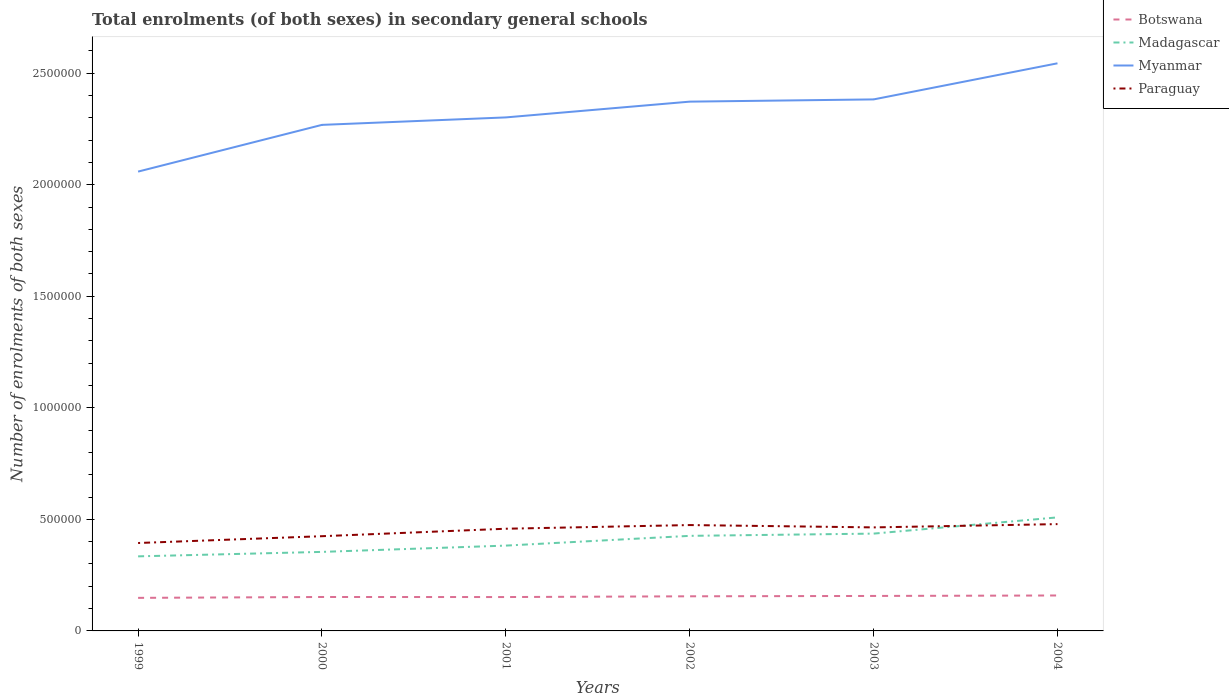How many different coloured lines are there?
Make the answer very short. 4. Does the line corresponding to Paraguay intersect with the line corresponding to Myanmar?
Make the answer very short. No. Across all years, what is the maximum number of enrolments in secondary schools in Paraguay?
Your answer should be very brief. 3.94e+05. What is the total number of enrolments in secondary schools in Paraguay in the graph?
Your answer should be compact. -3.94e+04. What is the difference between the highest and the second highest number of enrolments in secondary schools in Myanmar?
Make the answer very short. 4.85e+05. Is the number of enrolments in secondary schools in Myanmar strictly greater than the number of enrolments in secondary schools in Botswana over the years?
Your answer should be very brief. No. How many lines are there?
Provide a short and direct response. 4. What is the difference between two consecutive major ticks on the Y-axis?
Give a very brief answer. 5.00e+05. How are the legend labels stacked?
Offer a very short reply. Vertical. What is the title of the graph?
Your answer should be compact. Total enrolments (of both sexes) in secondary general schools. What is the label or title of the X-axis?
Ensure brevity in your answer.  Years. What is the label or title of the Y-axis?
Your answer should be very brief. Number of enrolments of both sexes. What is the Number of enrolments of both sexes in Botswana in 1999?
Provide a short and direct response. 1.48e+05. What is the Number of enrolments of both sexes in Madagascar in 1999?
Give a very brief answer. 3.34e+05. What is the Number of enrolments of both sexes in Myanmar in 1999?
Provide a short and direct response. 2.06e+06. What is the Number of enrolments of both sexes in Paraguay in 1999?
Your response must be concise. 3.94e+05. What is the Number of enrolments of both sexes of Botswana in 2000?
Provide a short and direct response. 1.52e+05. What is the Number of enrolments of both sexes in Madagascar in 2000?
Offer a very short reply. 3.54e+05. What is the Number of enrolments of both sexes of Myanmar in 2000?
Your response must be concise. 2.27e+06. What is the Number of enrolments of both sexes of Paraguay in 2000?
Your response must be concise. 4.25e+05. What is the Number of enrolments of both sexes in Botswana in 2001?
Offer a very short reply. 1.52e+05. What is the Number of enrolments of both sexes of Madagascar in 2001?
Give a very brief answer. 3.82e+05. What is the Number of enrolments of both sexes of Myanmar in 2001?
Your response must be concise. 2.30e+06. What is the Number of enrolments of both sexes in Paraguay in 2001?
Your answer should be compact. 4.58e+05. What is the Number of enrolments of both sexes of Botswana in 2002?
Your answer should be very brief. 1.55e+05. What is the Number of enrolments of both sexes of Madagascar in 2002?
Offer a terse response. 4.26e+05. What is the Number of enrolments of both sexes in Myanmar in 2002?
Provide a succinct answer. 2.37e+06. What is the Number of enrolments of both sexes in Paraguay in 2002?
Give a very brief answer. 4.75e+05. What is the Number of enrolments of both sexes in Botswana in 2003?
Give a very brief answer. 1.57e+05. What is the Number of enrolments of both sexes in Madagascar in 2003?
Your answer should be very brief. 4.36e+05. What is the Number of enrolments of both sexes in Myanmar in 2003?
Your response must be concise. 2.38e+06. What is the Number of enrolments of both sexes of Paraguay in 2003?
Keep it short and to the point. 4.64e+05. What is the Number of enrolments of both sexes in Botswana in 2004?
Your answer should be compact. 1.59e+05. What is the Number of enrolments of both sexes of Madagascar in 2004?
Give a very brief answer. 5.09e+05. What is the Number of enrolments of both sexes of Myanmar in 2004?
Your answer should be very brief. 2.54e+06. What is the Number of enrolments of both sexes of Paraguay in 2004?
Your answer should be compact. 4.79e+05. Across all years, what is the maximum Number of enrolments of both sexes of Botswana?
Your response must be concise. 1.59e+05. Across all years, what is the maximum Number of enrolments of both sexes in Madagascar?
Make the answer very short. 5.09e+05. Across all years, what is the maximum Number of enrolments of both sexes in Myanmar?
Your response must be concise. 2.54e+06. Across all years, what is the maximum Number of enrolments of both sexes of Paraguay?
Offer a terse response. 4.79e+05. Across all years, what is the minimum Number of enrolments of both sexes in Botswana?
Give a very brief answer. 1.48e+05. Across all years, what is the minimum Number of enrolments of both sexes of Madagascar?
Your response must be concise. 3.34e+05. Across all years, what is the minimum Number of enrolments of both sexes in Myanmar?
Your response must be concise. 2.06e+06. Across all years, what is the minimum Number of enrolments of both sexes in Paraguay?
Your answer should be very brief. 3.94e+05. What is the total Number of enrolments of both sexes of Botswana in the graph?
Keep it short and to the point. 9.23e+05. What is the total Number of enrolments of both sexes of Madagascar in the graph?
Provide a succinct answer. 2.44e+06. What is the total Number of enrolments of both sexes of Myanmar in the graph?
Give a very brief answer. 1.39e+07. What is the total Number of enrolments of both sexes in Paraguay in the graph?
Offer a terse response. 2.69e+06. What is the difference between the Number of enrolments of both sexes of Botswana in 1999 and that in 2000?
Offer a very short reply. -3910. What is the difference between the Number of enrolments of both sexes of Madagascar in 1999 and that in 2000?
Provide a succinct answer. -2.00e+04. What is the difference between the Number of enrolments of both sexes in Myanmar in 1999 and that in 2000?
Keep it short and to the point. -2.09e+05. What is the difference between the Number of enrolments of both sexes of Paraguay in 1999 and that in 2000?
Make the answer very short. -3.05e+04. What is the difference between the Number of enrolments of both sexes of Botswana in 1999 and that in 2001?
Your answer should be compact. -3652. What is the difference between the Number of enrolments of both sexes of Madagascar in 1999 and that in 2001?
Your answer should be compact. -4.82e+04. What is the difference between the Number of enrolments of both sexes of Myanmar in 1999 and that in 2001?
Provide a succinct answer. -2.43e+05. What is the difference between the Number of enrolments of both sexes of Paraguay in 1999 and that in 2001?
Provide a short and direct response. -6.40e+04. What is the difference between the Number of enrolments of both sexes of Botswana in 1999 and that in 2002?
Your answer should be very brief. -7012. What is the difference between the Number of enrolments of both sexes in Madagascar in 1999 and that in 2002?
Provide a succinct answer. -9.19e+04. What is the difference between the Number of enrolments of both sexes of Myanmar in 1999 and that in 2002?
Make the answer very short. -3.14e+05. What is the difference between the Number of enrolments of both sexes of Paraguay in 1999 and that in 2002?
Make the answer very short. -8.05e+04. What is the difference between the Number of enrolments of both sexes in Botswana in 1999 and that in 2003?
Offer a terse response. -8591. What is the difference between the Number of enrolments of both sexes in Madagascar in 1999 and that in 2003?
Give a very brief answer. -1.02e+05. What is the difference between the Number of enrolments of both sexes of Myanmar in 1999 and that in 2003?
Make the answer very short. -3.24e+05. What is the difference between the Number of enrolments of both sexes in Paraguay in 1999 and that in 2003?
Your response must be concise. -7.00e+04. What is the difference between the Number of enrolments of both sexes in Botswana in 1999 and that in 2004?
Ensure brevity in your answer.  -1.06e+04. What is the difference between the Number of enrolments of both sexes of Madagascar in 1999 and that in 2004?
Offer a very short reply. -1.75e+05. What is the difference between the Number of enrolments of both sexes of Myanmar in 1999 and that in 2004?
Provide a short and direct response. -4.85e+05. What is the difference between the Number of enrolments of both sexes of Paraguay in 1999 and that in 2004?
Your response must be concise. -8.47e+04. What is the difference between the Number of enrolments of both sexes in Botswana in 2000 and that in 2001?
Give a very brief answer. 258. What is the difference between the Number of enrolments of both sexes of Madagascar in 2000 and that in 2001?
Offer a very short reply. -2.82e+04. What is the difference between the Number of enrolments of both sexes of Myanmar in 2000 and that in 2001?
Ensure brevity in your answer.  -3.35e+04. What is the difference between the Number of enrolments of both sexes in Paraguay in 2000 and that in 2001?
Provide a succinct answer. -3.35e+04. What is the difference between the Number of enrolments of both sexes in Botswana in 2000 and that in 2002?
Keep it short and to the point. -3102. What is the difference between the Number of enrolments of both sexes of Madagascar in 2000 and that in 2002?
Keep it short and to the point. -7.19e+04. What is the difference between the Number of enrolments of both sexes of Myanmar in 2000 and that in 2002?
Offer a very short reply. -1.04e+05. What is the difference between the Number of enrolments of both sexes in Paraguay in 2000 and that in 2002?
Offer a terse response. -4.99e+04. What is the difference between the Number of enrolments of both sexes in Botswana in 2000 and that in 2003?
Keep it short and to the point. -4681. What is the difference between the Number of enrolments of both sexes in Madagascar in 2000 and that in 2003?
Give a very brief answer. -8.20e+04. What is the difference between the Number of enrolments of both sexes in Myanmar in 2000 and that in 2003?
Your answer should be very brief. -1.14e+05. What is the difference between the Number of enrolments of both sexes of Paraguay in 2000 and that in 2003?
Make the answer very short. -3.94e+04. What is the difference between the Number of enrolments of both sexes in Botswana in 2000 and that in 2004?
Your answer should be compact. -6734. What is the difference between the Number of enrolments of both sexes in Madagascar in 2000 and that in 2004?
Keep it short and to the point. -1.55e+05. What is the difference between the Number of enrolments of both sexes in Myanmar in 2000 and that in 2004?
Make the answer very short. -2.76e+05. What is the difference between the Number of enrolments of both sexes of Paraguay in 2000 and that in 2004?
Your answer should be compact. -5.42e+04. What is the difference between the Number of enrolments of both sexes of Botswana in 2001 and that in 2002?
Ensure brevity in your answer.  -3360. What is the difference between the Number of enrolments of both sexes in Madagascar in 2001 and that in 2002?
Your answer should be compact. -4.37e+04. What is the difference between the Number of enrolments of both sexes in Myanmar in 2001 and that in 2002?
Your answer should be compact. -7.07e+04. What is the difference between the Number of enrolments of both sexes in Paraguay in 2001 and that in 2002?
Offer a very short reply. -1.65e+04. What is the difference between the Number of enrolments of both sexes in Botswana in 2001 and that in 2003?
Offer a terse response. -4939. What is the difference between the Number of enrolments of both sexes of Madagascar in 2001 and that in 2003?
Your answer should be compact. -5.37e+04. What is the difference between the Number of enrolments of both sexes of Myanmar in 2001 and that in 2003?
Keep it short and to the point. -8.07e+04. What is the difference between the Number of enrolments of both sexes in Paraguay in 2001 and that in 2003?
Provide a succinct answer. -5988. What is the difference between the Number of enrolments of both sexes in Botswana in 2001 and that in 2004?
Ensure brevity in your answer.  -6992. What is the difference between the Number of enrolments of both sexes in Madagascar in 2001 and that in 2004?
Offer a terse response. -1.26e+05. What is the difference between the Number of enrolments of both sexes in Myanmar in 2001 and that in 2004?
Offer a terse response. -2.43e+05. What is the difference between the Number of enrolments of both sexes of Paraguay in 2001 and that in 2004?
Make the answer very short. -2.07e+04. What is the difference between the Number of enrolments of both sexes in Botswana in 2002 and that in 2003?
Offer a terse response. -1579. What is the difference between the Number of enrolments of both sexes of Madagascar in 2002 and that in 2003?
Keep it short and to the point. -1.00e+04. What is the difference between the Number of enrolments of both sexes in Myanmar in 2002 and that in 2003?
Provide a short and direct response. -1.00e+04. What is the difference between the Number of enrolments of both sexes of Paraguay in 2002 and that in 2003?
Give a very brief answer. 1.05e+04. What is the difference between the Number of enrolments of both sexes in Botswana in 2002 and that in 2004?
Your answer should be compact. -3632. What is the difference between the Number of enrolments of both sexes in Madagascar in 2002 and that in 2004?
Offer a terse response. -8.28e+04. What is the difference between the Number of enrolments of both sexes of Myanmar in 2002 and that in 2004?
Ensure brevity in your answer.  -1.72e+05. What is the difference between the Number of enrolments of both sexes in Paraguay in 2002 and that in 2004?
Make the answer very short. -4249. What is the difference between the Number of enrolments of both sexes in Botswana in 2003 and that in 2004?
Ensure brevity in your answer.  -2053. What is the difference between the Number of enrolments of both sexes in Madagascar in 2003 and that in 2004?
Give a very brief answer. -7.28e+04. What is the difference between the Number of enrolments of both sexes of Myanmar in 2003 and that in 2004?
Your answer should be compact. -1.62e+05. What is the difference between the Number of enrolments of both sexes in Paraguay in 2003 and that in 2004?
Offer a very short reply. -1.47e+04. What is the difference between the Number of enrolments of both sexes of Botswana in 1999 and the Number of enrolments of both sexes of Madagascar in 2000?
Provide a short and direct response. -2.06e+05. What is the difference between the Number of enrolments of both sexes of Botswana in 1999 and the Number of enrolments of both sexes of Myanmar in 2000?
Ensure brevity in your answer.  -2.12e+06. What is the difference between the Number of enrolments of both sexes of Botswana in 1999 and the Number of enrolments of both sexes of Paraguay in 2000?
Ensure brevity in your answer.  -2.76e+05. What is the difference between the Number of enrolments of both sexes in Madagascar in 1999 and the Number of enrolments of both sexes in Myanmar in 2000?
Give a very brief answer. -1.93e+06. What is the difference between the Number of enrolments of both sexes in Madagascar in 1999 and the Number of enrolments of both sexes in Paraguay in 2000?
Offer a terse response. -9.04e+04. What is the difference between the Number of enrolments of both sexes of Myanmar in 1999 and the Number of enrolments of both sexes of Paraguay in 2000?
Keep it short and to the point. 1.63e+06. What is the difference between the Number of enrolments of both sexes in Botswana in 1999 and the Number of enrolments of both sexes in Madagascar in 2001?
Your answer should be very brief. -2.34e+05. What is the difference between the Number of enrolments of both sexes in Botswana in 1999 and the Number of enrolments of both sexes in Myanmar in 2001?
Your answer should be compact. -2.15e+06. What is the difference between the Number of enrolments of both sexes in Botswana in 1999 and the Number of enrolments of both sexes in Paraguay in 2001?
Offer a terse response. -3.10e+05. What is the difference between the Number of enrolments of both sexes of Madagascar in 1999 and the Number of enrolments of both sexes of Myanmar in 2001?
Make the answer very short. -1.97e+06. What is the difference between the Number of enrolments of both sexes of Madagascar in 1999 and the Number of enrolments of both sexes of Paraguay in 2001?
Keep it short and to the point. -1.24e+05. What is the difference between the Number of enrolments of both sexes of Myanmar in 1999 and the Number of enrolments of both sexes of Paraguay in 2001?
Give a very brief answer. 1.60e+06. What is the difference between the Number of enrolments of both sexes of Botswana in 1999 and the Number of enrolments of both sexes of Madagascar in 2002?
Offer a very short reply. -2.78e+05. What is the difference between the Number of enrolments of both sexes of Botswana in 1999 and the Number of enrolments of both sexes of Myanmar in 2002?
Your response must be concise. -2.22e+06. What is the difference between the Number of enrolments of both sexes of Botswana in 1999 and the Number of enrolments of both sexes of Paraguay in 2002?
Your answer should be compact. -3.26e+05. What is the difference between the Number of enrolments of both sexes of Madagascar in 1999 and the Number of enrolments of both sexes of Myanmar in 2002?
Give a very brief answer. -2.04e+06. What is the difference between the Number of enrolments of both sexes of Madagascar in 1999 and the Number of enrolments of both sexes of Paraguay in 2002?
Offer a terse response. -1.40e+05. What is the difference between the Number of enrolments of both sexes in Myanmar in 1999 and the Number of enrolments of both sexes in Paraguay in 2002?
Give a very brief answer. 1.58e+06. What is the difference between the Number of enrolments of both sexes in Botswana in 1999 and the Number of enrolments of both sexes in Madagascar in 2003?
Offer a terse response. -2.88e+05. What is the difference between the Number of enrolments of both sexes of Botswana in 1999 and the Number of enrolments of both sexes of Myanmar in 2003?
Your response must be concise. -2.23e+06. What is the difference between the Number of enrolments of both sexes in Botswana in 1999 and the Number of enrolments of both sexes in Paraguay in 2003?
Your answer should be very brief. -3.16e+05. What is the difference between the Number of enrolments of both sexes of Madagascar in 1999 and the Number of enrolments of both sexes of Myanmar in 2003?
Give a very brief answer. -2.05e+06. What is the difference between the Number of enrolments of both sexes in Madagascar in 1999 and the Number of enrolments of both sexes in Paraguay in 2003?
Give a very brief answer. -1.30e+05. What is the difference between the Number of enrolments of both sexes in Myanmar in 1999 and the Number of enrolments of both sexes in Paraguay in 2003?
Your response must be concise. 1.59e+06. What is the difference between the Number of enrolments of both sexes of Botswana in 1999 and the Number of enrolments of both sexes of Madagascar in 2004?
Make the answer very short. -3.61e+05. What is the difference between the Number of enrolments of both sexes in Botswana in 1999 and the Number of enrolments of both sexes in Myanmar in 2004?
Provide a succinct answer. -2.40e+06. What is the difference between the Number of enrolments of both sexes of Botswana in 1999 and the Number of enrolments of both sexes of Paraguay in 2004?
Your answer should be very brief. -3.31e+05. What is the difference between the Number of enrolments of both sexes in Madagascar in 1999 and the Number of enrolments of both sexes in Myanmar in 2004?
Your answer should be compact. -2.21e+06. What is the difference between the Number of enrolments of both sexes in Madagascar in 1999 and the Number of enrolments of both sexes in Paraguay in 2004?
Your response must be concise. -1.45e+05. What is the difference between the Number of enrolments of both sexes of Myanmar in 1999 and the Number of enrolments of both sexes of Paraguay in 2004?
Your answer should be compact. 1.58e+06. What is the difference between the Number of enrolments of both sexes in Botswana in 2000 and the Number of enrolments of both sexes in Madagascar in 2001?
Ensure brevity in your answer.  -2.30e+05. What is the difference between the Number of enrolments of both sexes in Botswana in 2000 and the Number of enrolments of both sexes in Myanmar in 2001?
Keep it short and to the point. -2.15e+06. What is the difference between the Number of enrolments of both sexes in Botswana in 2000 and the Number of enrolments of both sexes in Paraguay in 2001?
Offer a very short reply. -3.06e+05. What is the difference between the Number of enrolments of both sexes in Madagascar in 2000 and the Number of enrolments of both sexes in Myanmar in 2001?
Your response must be concise. -1.95e+06. What is the difference between the Number of enrolments of both sexes of Madagascar in 2000 and the Number of enrolments of both sexes of Paraguay in 2001?
Provide a succinct answer. -1.04e+05. What is the difference between the Number of enrolments of both sexes in Myanmar in 2000 and the Number of enrolments of both sexes in Paraguay in 2001?
Your answer should be very brief. 1.81e+06. What is the difference between the Number of enrolments of both sexes of Botswana in 2000 and the Number of enrolments of both sexes of Madagascar in 2002?
Offer a terse response. -2.74e+05. What is the difference between the Number of enrolments of both sexes in Botswana in 2000 and the Number of enrolments of both sexes in Myanmar in 2002?
Keep it short and to the point. -2.22e+06. What is the difference between the Number of enrolments of both sexes in Botswana in 2000 and the Number of enrolments of both sexes in Paraguay in 2002?
Your answer should be compact. -3.22e+05. What is the difference between the Number of enrolments of both sexes in Madagascar in 2000 and the Number of enrolments of both sexes in Myanmar in 2002?
Make the answer very short. -2.02e+06. What is the difference between the Number of enrolments of both sexes of Madagascar in 2000 and the Number of enrolments of both sexes of Paraguay in 2002?
Give a very brief answer. -1.20e+05. What is the difference between the Number of enrolments of both sexes in Myanmar in 2000 and the Number of enrolments of both sexes in Paraguay in 2002?
Provide a succinct answer. 1.79e+06. What is the difference between the Number of enrolments of both sexes of Botswana in 2000 and the Number of enrolments of both sexes of Madagascar in 2003?
Ensure brevity in your answer.  -2.84e+05. What is the difference between the Number of enrolments of both sexes in Botswana in 2000 and the Number of enrolments of both sexes in Myanmar in 2003?
Make the answer very short. -2.23e+06. What is the difference between the Number of enrolments of both sexes in Botswana in 2000 and the Number of enrolments of both sexes in Paraguay in 2003?
Offer a very short reply. -3.12e+05. What is the difference between the Number of enrolments of both sexes in Madagascar in 2000 and the Number of enrolments of both sexes in Myanmar in 2003?
Your answer should be very brief. -2.03e+06. What is the difference between the Number of enrolments of both sexes in Madagascar in 2000 and the Number of enrolments of both sexes in Paraguay in 2003?
Ensure brevity in your answer.  -1.10e+05. What is the difference between the Number of enrolments of both sexes in Myanmar in 2000 and the Number of enrolments of both sexes in Paraguay in 2003?
Keep it short and to the point. 1.80e+06. What is the difference between the Number of enrolments of both sexes in Botswana in 2000 and the Number of enrolments of both sexes in Madagascar in 2004?
Provide a short and direct response. -3.57e+05. What is the difference between the Number of enrolments of both sexes of Botswana in 2000 and the Number of enrolments of both sexes of Myanmar in 2004?
Your answer should be compact. -2.39e+06. What is the difference between the Number of enrolments of both sexes in Botswana in 2000 and the Number of enrolments of both sexes in Paraguay in 2004?
Make the answer very short. -3.27e+05. What is the difference between the Number of enrolments of both sexes of Madagascar in 2000 and the Number of enrolments of both sexes of Myanmar in 2004?
Ensure brevity in your answer.  -2.19e+06. What is the difference between the Number of enrolments of both sexes of Madagascar in 2000 and the Number of enrolments of both sexes of Paraguay in 2004?
Keep it short and to the point. -1.25e+05. What is the difference between the Number of enrolments of both sexes of Myanmar in 2000 and the Number of enrolments of both sexes of Paraguay in 2004?
Provide a short and direct response. 1.79e+06. What is the difference between the Number of enrolments of both sexes of Botswana in 2001 and the Number of enrolments of both sexes of Madagascar in 2002?
Ensure brevity in your answer.  -2.74e+05. What is the difference between the Number of enrolments of both sexes of Botswana in 2001 and the Number of enrolments of both sexes of Myanmar in 2002?
Ensure brevity in your answer.  -2.22e+06. What is the difference between the Number of enrolments of both sexes of Botswana in 2001 and the Number of enrolments of both sexes of Paraguay in 2002?
Make the answer very short. -3.23e+05. What is the difference between the Number of enrolments of both sexes of Madagascar in 2001 and the Number of enrolments of both sexes of Myanmar in 2002?
Your answer should be compact. -1.99e+06. What is the difference between the Number of enrolments of both sexes of Madagascar in 2001 and the Number of enrolments of both sexes of Paraguay in 2002?
Your answer should be very brief. -9.21e+04. What is the difference between the Number of enrolments of both sexes of Myanmar in 2001 and the Number of enrolments of both sexes of Paraguay in 2002?
Provide a short and direct response. 1.83e+06. What is the difference between the Number of enrolments of both sexes in Botswana in 2001 and the Number of enrolments of both sexes in Madagascar in 2003?
Your answer should be very brief. -2.84e+05. What is the difference between the Number of enrolments of both sexes of Botswana in 2001 and the Number of enrolments of both sexes of Myanmar in 2003?
Offer a terse response. -2.23e+06. What is the difference between the Number of enrolments of both sexes in Botswana in 2001 and the Number of enrolments of both sexes in Paraguay in 2003?
Your answer should be very brief. -3.12e+05. What is the difference between the Number of enrolments of both sexes in Madagascar in 2001 and the Number of enrolments of both sexes in Myanmar in 2003?
Give a very brief answer. -2.00e+06. What is the difference between the Number of enrolments of both sexes of Madagascar in 2001 and the Number of enrolments of both sexes of Paraguay in 2003?
Offer a very short reply. -8.16e+04. What is the difference between the Number of enrolments of both sexes in Myanmar in 2001 and the Number of enrolments of both sexes in Paraguay in 2003?
Keep it short and to the point. 1.84e+06. What is the difference between the Number of enrolments of both sexes of Botswana in 2001 and the Number of enrolments of both sexes of Madagascar in 2004?
Provide a short and direct response. -3.57e+05. What is the difference between the Number of enrolments of both sexes in Botswana in 2001 and the Number of enrolments of both sexes in Myanmar in 2004?
Your answer should be compact. -2.39e+06. What is the difference between the Number of enrolments of both sexes in Botswana in 2001 and the Number of enrolments of both sexes in Paraguay in 2004?
Provide a short and direct response. -3.27e+05. What is the difference between the Number of enrolments of both sexes of Madagascar in 2001 and the Number of enrolments of both sexes of Myanmar in 2004?
Keep it short and to the point. -2.16e+06. What is the difference between the Number of enrolments of both sexes in Madagascar in 2001 and the Number of enrolments of both sexes in Paraguay in 2004?
Ensure brevity in your answer.  -9.63e+04. What is the difference between the Number of enrolments of both sexes in Myanmar in 2001 and the Number of enrolments of both sexes in Paraguay in 2004?
Offer a terse response. 1.82e+06. What is the difference between the Number of enrolments of both sexes of Botswana in 2002 and the Number of enrolments of both sexes of Madagascar in 2003?
Give a very brief answer. -2.81e+05. What is the difference between the Number of enrolments of both sexes of Botswana in 2002 and the Number of enrolments of both sexes of Myanmar in 2003?
Your answer should be compact. -2.23e+06. What is the difference between the Number of enrolments of both sexes in Botswana in 2002 and the Number of enrolments of both sexes in Paraguay in 2003?
Your response must be concise. -3.09e+05. What is the difference between the Number of enrolments of both sexes of Madagascar in 2002 and the Number of enrolments of both sexes of Myanmar in 2003?
Ensure brevity in your answer.  -1.96e+06. What is the difference between the Number of enrolments of both sexes of Madagascar in 2002 and the Number of enrolments of both sexes of Paraguay in 2003?
Ensure brevity in your answer.  -3.79e+04. What is the difference between the Number of enrolments of both sexes of Myanmar in 2002 and the Number of enrolments of both sexes of Paraguay in 2003?
Offer a very short reply. 1.91e+06. What is the difference between the Number of enrolments of both sexes of Botswana in 2002 and the Number of enrolments of both sexes of Madagascar in 2004?
Give a very brief answer. -3.54e+05. What is the difference between the Number of enrolments of both sexes of Botswana in 2002 and the Number of enrolments of both sexes of Myanmar in 2004?
Make the answer very short. -2.39e+06. What is the difference between the Number of enrolments of both sexes in Botswana in 2002 and the Number of enrolments of both sexes in Paraguay in 2004?
Keep it short and to the point. -3.24e+05. What is the difference between the Number of enrolments of both sexes of Madagascar in 2002 and the Number of enrolments of both sexes of Myanmar in 2004?
Your response must be concise. -2.12e+06. What is the difference between the Number of enrolments of both sexes of Madagascar in 2002 and the Number of enrolments of both sexes of Paraguay in 2004?
Provide a succinct answer. -5.26e+04. What is the difference between the Number of enrolments of both sexes of Myanmar in 2002 and the Number of enrolments of both sexes of Paraguay in 2004?
Provide a succinct answer. 1.89e+06. What is the difference between the Number of enrolments of both sexes of Botswana in 2003 and the Number of enrolments of both sexes of Madagascar in 2004?
Provide a succinct answer. -3.52e+05. What is the difference between the Number of enrolments of both sexes in Botswana in 2003 and the Number of enrolments of both sexes in Myanmar in 2004?
Provide a succinct answer. -2.39e+06. What is the difference between the Number of enrolments of both sexes in Botswana in 2003 and the Number of enrolments of both sexes in Paraguay in 2004?
Offer a terse response. -3.22e+05. What is the difference between the Number of enrolments of both sexes of Madagascar in 2003 and the Number of enrolments of both sexes of Myanmar in 2004?
Your response must be concise. -2.11e+06. What is the difference between the Number of enrolments of both sexes of Madagascar in 2003 and the Number of enrolments of both sexes of Paraguay in 2004?
Keep it short and to the point. -4.26e+04. What is the difference between the Number of enrolments of both sexes in Myanmar in 2003 and the Number of enrolments of both sexes in Paraguay in 2004?
Your response must be concise. 1.90e+06. What is the average Number of enrolments of both sexes of Botswana per year?
Provide a succinct answer. 1.54e+05. What is the average Number of enrolments of both sexes of Madagascar per year?
Provide a short and direct response. 4.07e+05. What is the average Number of enrolments of both sexes in Myanmar per year?
Provide a short and direct response. 2.32e+06. What is the average Number of enrolments of both sexes of Paraguay per year?
Offer a very short reply. 4.49e+05. In the year 1999, what is the difference between the Number of enrolments of both sexes of Botswana and Number of enrolments of both sexes of Madagascar?
Your answer should be compact. -1.86e+05. In the year 1999, what is the difference between the Number of enrolments of both sexes of Botswana and Number of enrolments of both sexes of Myanmar?
Offer a terse response. -1.91e+06. In the year 1999, what is the difference between the Number of enrolments of both sexes in Botswana and Number of enrolments of both sexes in Paraguay?
Make the answer very short. -2.46e+05. In the year 1999, what is the difference between the Number of enrolments of both sexes of Madagascar and Number of enrolments of both sexes of Myanmar?
Provide a succinct answer. -1.72e+06. In the year 1999, what is the difference between the Number of enrolments of both sexes in Madagascar and Number of enrolments of both sexes in Paraguay?
Provide a succinct answer. -5.98e+04. In the year 1999, what is the difference between the Number of enrolments of both sexes in Myanmar and Number of enrolments of both sexes in Paraguay?
Your answer should be compact. 1.66e+06. In the year 2000, what is the difference between the Number of enrolments of both sexes in Botswana and Number of enrolments of both sexes in Madagascar?
Make the answer very short. -2.02e+05. In the year 2000, what is the difference between the Number of enrolments of both sexes in Botswana and Number of enrolments of both sexes in Myanmar?
Your answer should be compact. -2.12e+06. In the year 2000, what is the difference between the Number of enrolments of both sexes of Botswana and Number of enrolments of both sexes of Paraguay?
Offer a very short reply. -2.73e+05. In the year 2000, what is the difference between the Number of enrolments of both sexes in Madagascar and Number of enrolments of both sexes in Myanmar?
Provide a short and direct response. -1.91e+06. In the year 2000, what is the difference between the Number of enrolments of both sexes of Madagascar and Number of enrolments of both sexes of Paraguay?
Give a very brief answer. -7.04e+04. In the year 2000, what is the difference between the Number of enrolments of both sexes in Myanmar and Number of enrolments of both sexes in Paraguay?
Provide a succinct answer. 1.84e+06. In the year 2001, what is the difference between the Number of enrolments of both sexes of Botswana and Number of enrolments of both sexes of Madagascar?
Provide a short and direct response. -2.31e+05. In the year 2001, what is the difference between the Number of enrolments of both sexes of Botswana and Number of enrolments of both sexes of Myanmar?
Give a very brief answer. -2.15e+06. In the year 2001, what is the difference between the Number of enrolments of both sexes in Botswana and Number of enrolments of both sexes in Paraguay?
Make the answer very short. -3.06e+05. In the year 2001, what is the difference between the Number of enrolments of both sexes in Madagascar and Number of enrolments of both sexes in Myanmar?
Give a very brief answer. -1.92e+06. In the year 2001, what is the difference between the Number of enrolments of both sexes in Madagascar and Number of enrolments of both sexes in Paraguay?
Offer a very short reply. -7.56e+04. In the year 2001, what is the difference between the Number of enrolments of both sexes of Myanmar and Number of enrolments of both sexes of Paraguay?
Give a very brief answer. 1.84e+06. In the year 2002, what is the difference between the Number of enrolments of both sexes of Botswana and Number of enrolments of both sexes of Madagascar?
Make the answer very short. -2.71e+05. In the year 2002, what is the difference between the Number of enrolments of both sexes of Botswana and Number of enrolments of both sexes of Myanmar?
Keep it short and to the point. -2.22e+06. In the year 2002, what is the difference between the Number of enrolments of both sexes of Botswana and Number of enrolments of both sexes of Paraguay?
Give a very brief answer. -3.19e+05. In the year 2002, what is the difference between the Number of enrolments of both sexes in Madagascar and Number of enrolments of both sexes in Myanmar?
Make the answer very short. -1.95e+06. In the year 2002, what is the difference between the Number of enrolments of both sexes in Madagascar and Number of enrolments of both sexes in Paraguay?
Offer a terse response. -4.84e+04. In the year 2002, what is the difference between the Number of enrolments of both sexes of Myanmar and Number of enrolments of both sexes of Paraguay?
Ensure brevity in your answer.  1.90e+06. In the year 2003, what is the difference between the Number of enrolments of both sexes of Botswana and Number of enrolments of both sexes of Madagascar?
Give a very brief answer. -2.79e+05. In the year 2003, what is the difference between the Number of enrolments of both sexes of Botswana and Number of enrolments of both sexes of Myanmar?
Your response must be concise. -2.23e+06. In the year 2003, what is the difference between the Number of enrolments of both sexes of Botswana and Number of enrolments of both sexes of Paraguay?
Ensure brevity in your answer.  -3.07e+05. In the year 2003, what is the difference between the Number of enrolments of both sexes in Madagascar and Number of enrolments of both sexes in Myanmar?
Make the answer very short. -1.95e+06. In the year 2003, what is the difference between the Number of enrolments of both sexes in Madagascar and Number of enrolments of both sexes in Paraguay?
Your answer should be compact. -2.79e+04. In the year 2003, what is the difference between the Number of enrolments of both sexes in Myanmar and Number of enrolments of both sexes in Paraguay?
Give a very brief answer. 1.92e+06. In the year 2004, what is the difference between the Number of enrolments of both sexes of Botswana and Number of enrolments of both sexes of Madagascar?
Keep it short and to the point. -3.50e+05. In the year 2004, what is the difference between the Number of enrolments of both sexes of Botswana and Number of enrolments of both sexes of Myanmar?
Ensure brevity in your answer.  -2.39e+06. In the year 2004, what is the difference between the Number of enrolments of both sexes of Botswana and Number of enrolments of both sexes of Paraguay?
Offer a terse response. -3.20e+05. In the year 2004, what is the difference between the Number of enrolments of both sexes in Madagascar and Number of enrolments of both sexes in Myanmar?
Ensure brevity in your answer.  -2.04e+06. In the year 2004, what is the difference between the Number of enrolments of both sexes of Madagascar and Number of enrolments of both sexes of Paraguay?
Your answer should be compact. 3.02e+04. In the year 2004, what is the difference between the Number of enrolments of both sexes of Myanmar and Number of enrolments of both sexes of Paraguay?
Offer a terse response. 2.07e+06. What is the ratio of the Number of enrolments of both sexes in Botswana in 1999 to that in 2000?
Ensure brevity in your answer.  0.97. What is the ratio of the Number of enrolments of both sexes of Madagascar in 1999 to that in 2000?
Make the answer very short. 0.94. What is the ratio of the Number of enrolments of both sexes of Myanmar in 1999 to that in 2000?
Your response must be concise. 0.91. What is the ratio of the Number of enrolments of both sexes of Paraguay in 1999 to that in 2000?
Give a very brief answer. 0.93. What is the ratio of the Number of enrolments of both sexes of Botswana in 1999 to that in 2001?
Your answer should be compact. 0.98. What is the ratio of the Number of enrolments of both sexes in Madagascar in 1999 to that in 2001?
Make the answer very short. 0.87. What is the ratio of the Number of enrolments of both sexes of Myanmar in 1999 to that in 2001?
Give a very brief answer. 0.89. What is the ratio of the Number of enrolments of both sexes in Paraguay in 1999 to that in 2001?
Your answer should be very brief. 0.86. What is the ratio of the Number of enrolments of both sexes in Botswana in 1999 to that in 2002?
Offer a very short reply. 0.95. What is the ratio of the Number of enrolments of both sexes of Madagascar in 1999 to that in 2002?
Your answer should be very brief. 0.78. What is the ratio of the Number of enrolments of both sexes in Myanmar in 1999 to that in 2002?
Provide a succinct answer. 0.87. What is the ratio of the Number of enrolments of both sexes of Paraguay in 1999 to that in 2002?
Provide a succinct answer. 0.83. What is the ratio of the Number of enrolments of both sexes of Botswana in 1999 to that in 2003?
Provide a short and direct response. 0.95. What is the ratio of the Number of enrolments of both sexes of Madagascar in 1999 to that in 2003?
Provide a short and direct response. 0.77. What is the ratio of the Number of enrolments of both sexes of Myanmar in 1999 to that in 2003?
Make the answer very short. 0.86. What is the ratio of the Number of enrolments of both sexes in Paraguay in 1999 to that in 2003?
Offer a terse response. 0.85. What is the ratio of the Number of enrolments of both sexes of Botswana in 1999 to that in 2004?
Give a very brief answer. 0.93. What is the ratio of the Number of enrolments of both sexes in Madagascar in 1999 to that in 2004?
Make the answer very short. 0.66. What is the ratio of the Number of enrolments of both sexes of Myanmar in 1999 to that in 2004?
Your response must be concise. 0.81. What is the ratio of the Number of enrolments of both sexes in Paraguay in 1999 to that in 2004?
Your answer should be very brief. 0.82. What is the ratio of the Number of enrolments of both sexes in Botswana in 2000 to that in 2001?
Your answer should be compact. 1. What is the ratio of the Number of enrolments of both sexes of Madagascar in 2000 to that in 2001?
Offer a terse response. 0.93. What is the ratio of the Number of enrolments of both sexes in Myanmar in 2000 to that in 2001?
Offer a terse response. 0.99. What is the ratio of the Number of enrolments of both sexes in Paraguay in 2000 to that in 2001?
Your response must be concise. 0.93. What is the ratio of the Number of enrolments of both sexes of Madagascar in 2000 to that in 2002?
Offer a terse response. 0.83. What is the ratio of the Number of enrolments of both sexes of Myanmar in 2000 to that in 2002?
Make the answer very short. 0.96. What is the ratio of the Number of enrolments of both sexes of Paraguay in 2000 to that in 2002?
Ensure brevity in your answer.  0.89. What is the ratio of the Number of enrolments of both sexes in Botswana in 2000 to that in 2003?
Provide a short and direct response. 0.97. What is the ratio of the Number of enrolments of both sexes in Madagascar in 2000 to that in 2003?
Your answer should be compact. 0.81. What is the ratio of the Number of enrolments of both sexes in Myanmar in 2000 to that in 2003?
Ensure brevity in your answer.  0.95. What is the ratio of the Number of enrolments of both sexes in Paraguay in 2000 to that in 2003?
Offer a very short reply. 0.92. What is the ratio of the Number of enrolments of both sexes of Botswana in 2000 to that in 2004?
Ensure brevity in your answer.  0.96. What is the ratio of the Number of enrolments of both sexes in Madagascar in 2000 to that in 2004?
Your answer should be compact. 0.7. What is the ratio of the Number of enrolments of both sexes of Myanmar in 2000 to that in 2004?
Ensure brevity in your answer.  0.89. What is the ratio of the Number of enrolments of both sexes of Paraguay in 2000 to that in 2004?
Offer a very short reply. 0.89. What is the ratio of the Number of enrolments of both sexes in Botswana in 2001 to that in 2002?
Your answer should be compact. 0.98. What is the ratio of the Number of enrolments of both sexes in Madagascar in 2001 to that in 2002?
Ensure brevity in your answer.  0.9. What is the ratio of the Number of enrolments of both sexes of Myanmar in 2001 to that in 2002?
Your answer should be compact. 0.97. What is the ratio of the Number of enrolments of both sexes in Paraguay in 2001 to that in 2002?
Give a very brief answer. 0.97. What is the ratio of the Number of enrolments of both sexes of Botswana in 2001 to that in 2003?
Make the answer very short. 0.97. What is the ratio of the Number of enrolments of both sexes in Madagascar in 2001 to that in 2003?
Offer a very short reply. 0.88. What is the ratio of the Number of enrolments of both sexes of Myanmar in 2001 to that in 2003?
Your response must be concise. 0.97. What is the ratio of the Number of enrolments of both sexes in Paraguay in 2001 to that in 2003?
Offer a very short reply. 0.99. What is the ratio of the Number of enrolments of both sexes of Botswana in 2001 to that in 2004?
Your answer should be very brief. 0.96. What is the ratio of the Number of enrolments of both sexes in Madagascar in 2001 to that in 2004?
Provide a short and direct response. 0.75. What is the ratio of the Number of enrolments of both sexes in Myanmar in 2001 to that in 2004?
Give a very brief answer. 0.9. What is the ratio of the Number of enrolments of both sexes in Paraguay in 2001 to that in 2004?
Offer a very short reply. 0.96. What is the ratio of the Number of enrolments of both sexes in Madagascar in 2002 to that in 2003?
Give a very brief answer. 0.98. What is the ratio of the Number of enrolments of both sexes in Paraguay in 2002 to that in 2003?
Keep it short and to the point. 1.02. What is the ratio of the Number of enrolments of both sexes in Botswana in 2002 to that in 2004?
Keep it short and to the point. 0.98. What is the ratio of the Number of enrolments of both sexes of Madagascar in 2002 to that in 2004?
Your answer should be very brief. 0.84. What is the ratio of the Number of enrolments of both sexes in Myanmar in 2002 to that in 2004?
Your answer should be compact. 0.93. What is the ratio of the Number of enrolments of both sexes in Botswana in 2003 to that in 2004?
Your answer should be very brief. 0.99. What is the ratio of the Number of enrolments of both sexes of Madagascar in 2003 to that in 2004?
Make the answer very short. 0.86. What is the ratio of the Number of enrolments of both sexes in Myanmar in 2003 to that in 2004?
Provide a succinct answer. 0.94. What is the ratio of the Number of enrolments of both sexes of Paraguay in 2003 to that in 2004?
Offer a terse response. 0.97. What is the difference between the highest and the second highest Number of enrolments of both sexes in Botswana?
Make the answer very short. 2053. What is the difference between the highest and the second highest Number of enrolments of both sexes in Madagascar?
Provide a short and direct response. 7.28e+04. What is the difference between the highest and the second highest Number of enrolments of both sexes of Myanmar?
Provide a short and direct response. 1.62e+05. What is the difference between the highest and the second highest Number of enrolments of both sexes in Paraguay?
Provide a short and direct response. 4249. What is the difference between the highest and the lowest Number of enrolments of both sexes of Botswana?
Ensure brevity in your answer.  1.06e+04. What is the difference between the highest and the lowest Number of enrolments of both sexes of Madagascar?
Provide a short and direct response. 1.75e+05. What is the difference between the highest and the lowest Number of enrolments of both sexes of Myanmar?
Keep it short and to the point. 4.85e+05. What is the difference between the highest and the lowest Number of enrolments of both sexes of Paraguay?
Keep it short and to the point. 8.47e+04. 